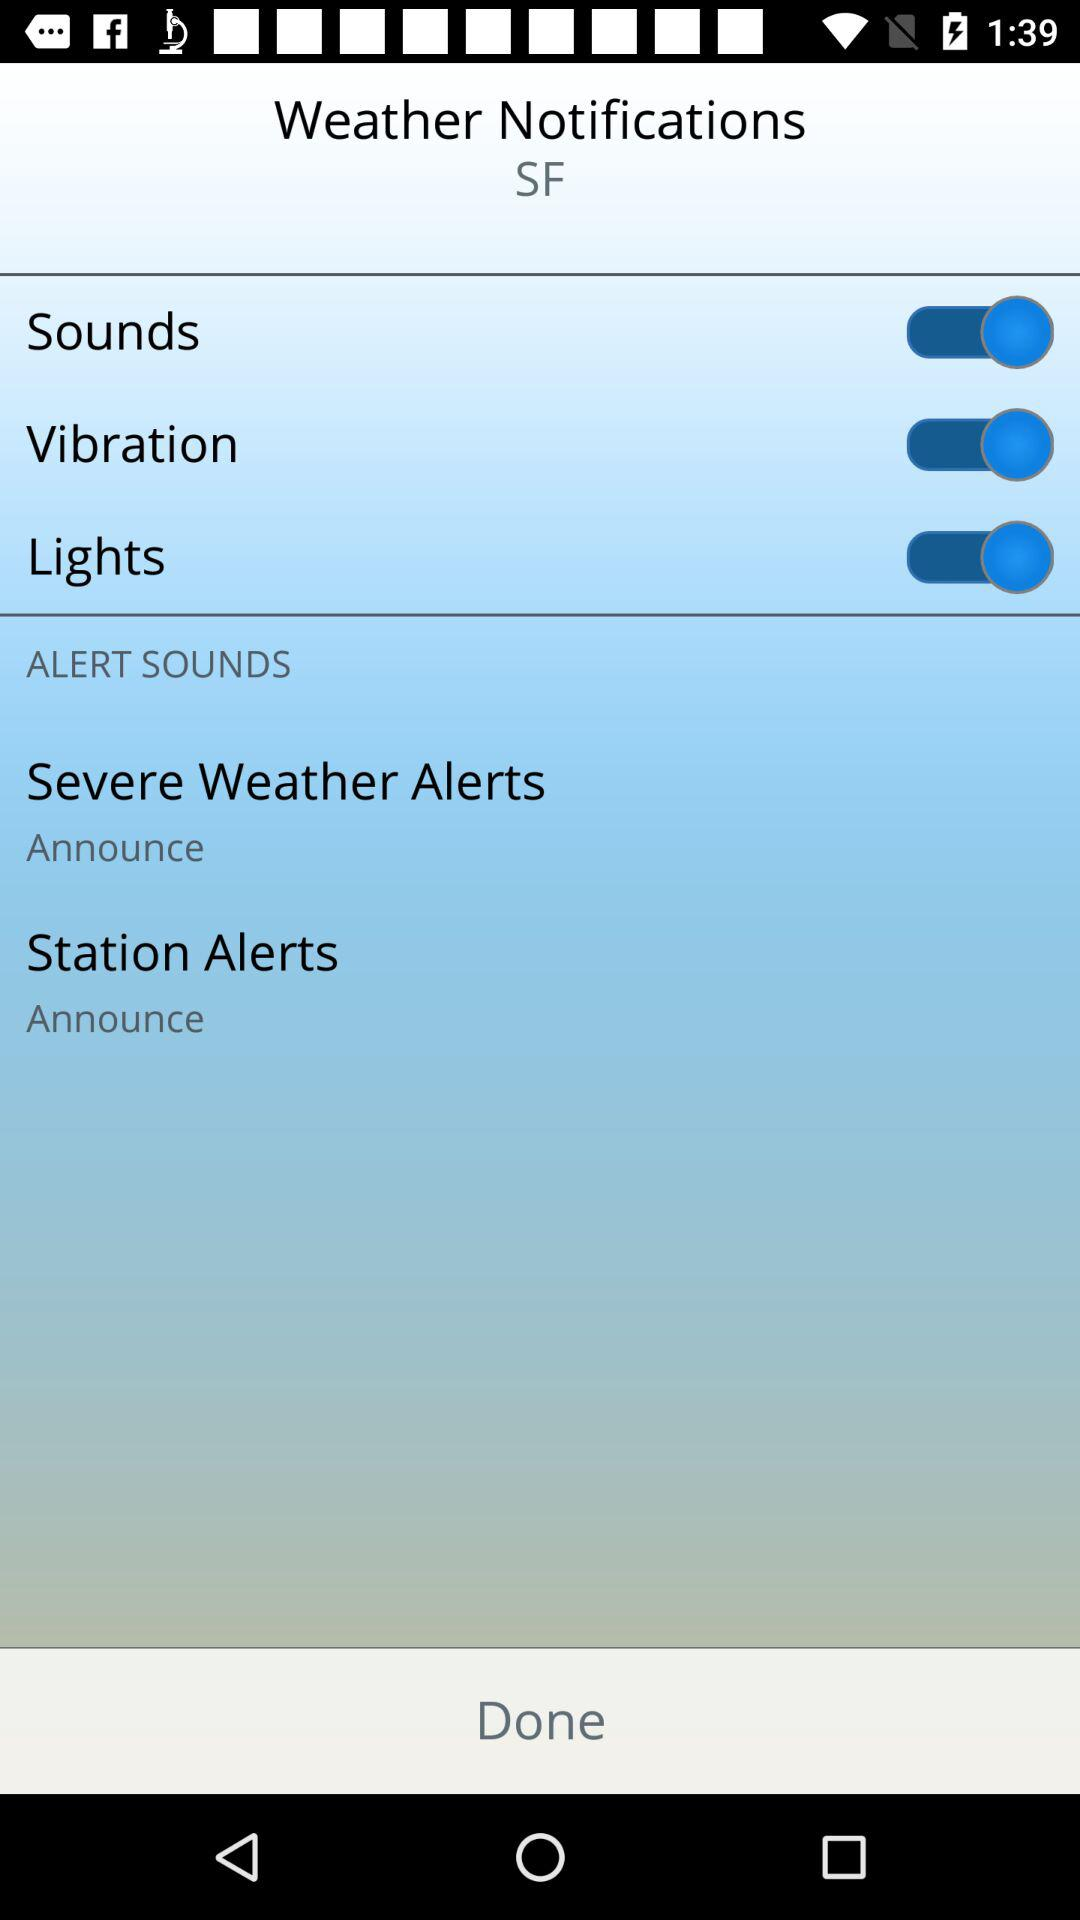How many alert sound options are there?
Answer the question using a single word or phrase. 2 